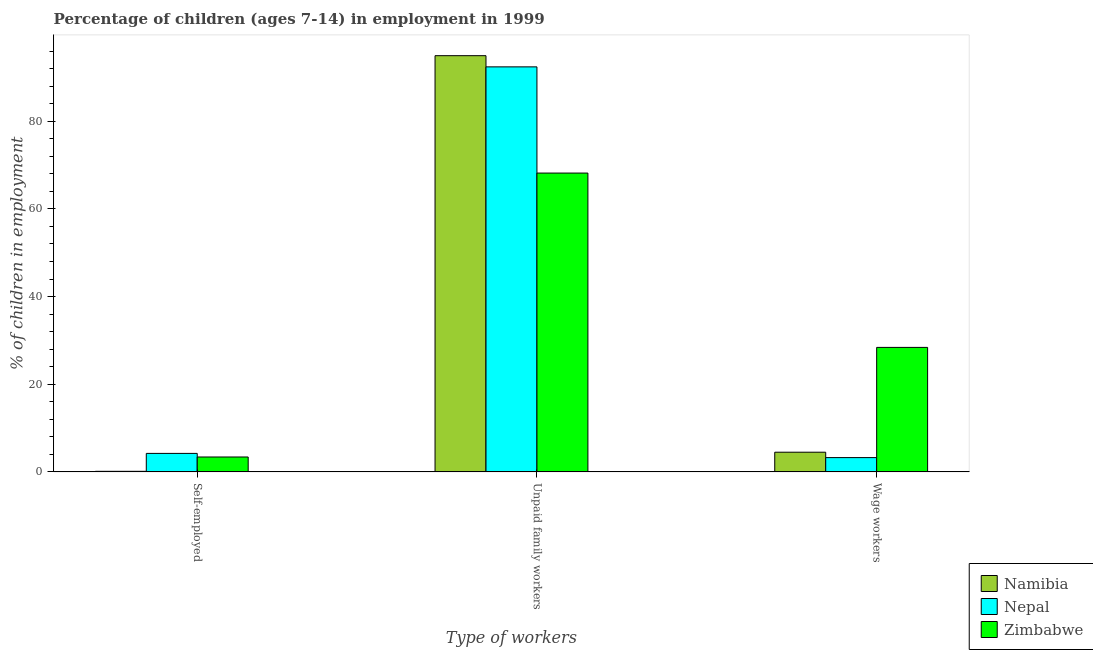How many different coloured bars are there?
Offer a very short reply. 3. How many bars are there on the 1st tick from the left?
Ensure brevity in your answer.  3. How many bars are there on the 3rd tick from the right?
Provide a succinct answer. 3. What is the label of the 1st group of bars from the left?
Keep it short and to the point. Self-employed. What is the percentage of children employed as unpaid family workers in Namibia?
Provide a short and direct response. 94.96. Across all countries, what is the maximum percentage of self employed children?
Provide a short and direct response. 4.23. Across all countries, what is the minimum percentage of children employed as wage workers?
Keep it short and to the point. 3.27. In which country was the percentage of self employed children maximum?
Offer a terse response. Nepal. In which country was the percentage of children employed as wage workers minimum?
Your answer should be compact. Nepal. What is the total percentage of children employed as wage workers in the graph?
Provide a succinct answer. 36.18. What is the difference between the percentage of children employed as unpaid family workers in Namibia and that in Nepal?
Offer a very short reply. 2.55. What is the difference between the percentage of children employed as unpaid family workers in Zimbabwe and the percentage of self employed children in Nepal?
Offer a very short reply. 63.95. What is the average percentage of children employed as wage workers per country?
Ensure brevity in your answer.  12.06. What is the difference between the percentage of children employed as unpaid family workers and percentage of children employed as wage workers in Namibia?
Make the answer very short. 90.46. What is the ratio of the percentage of children employed as wage workers in Zimbabwe to that in Nepal?
Your answer should be very brief. 8.69. Is the percentage of self employed children in Namibia less than that in Nepal?
Provide a short and direct response. Yes. What is the difference between the highest and the second highest percentage of self employed children?
Your answer should be very brief. 0.82. What is the difference between the highest and the lowest percentage of self employed children?
Provide a short and direct response. 4.09. What does the 3rd bar from the left in Unpaid family workers represents?
Provide a succinct answer. Zimbabwe. What does the 1st bar from the right in Unpaid family workers represents?
Ensure brevity in your answer.  Zimbabwe. Is it the case that in every country, the sum of the percentage of self employed children and percentage of children employed as unpaid family workers is greater than the percentage of children employed as wage workers?
Ensure brevity in your answer.  Yes. How many bars are there?
Offer a very short reply. 9. Does the graph contain any zero values?
Your response must be concise. No. Does the graph contain grids?
Provide a succinct answer. No. Where does the legend appear in the graph?
Give a very brief answer. Bottom right. How are the legend labels stacked?
Ensure brevity in your answer.  Vertical. What is the title of the graph?
Offer a very short reply. Percentage of children (ages 7-14) in employment in 1999. Does "Turkmenistan" appear as one of the legend labels in the graph?
Offer a terse response. No. What is the label or title of the X-axis?
Your answer should be very brief. Type of workers. What is the label or title of the Y-axis?
Offer a very short reply. % of children in employment. What is the % of children in employment in Namibia in Self-employed?
Provide a succinct answer. 0.14. What is the % of children in employment in Nepal in Self-employed?
Your response must be concise. 4.23. What is the % of children in employment of Zimbabwe in Self-employed?
Your response must be concise. 3.41. What is the % of children in employment of Namibia in Unpaid family workers?
Keep it short and to the point. 94.96. What is the % of children in employment of Nepal in Unpaid family workers?
Provide a short and direct response. 92.41. What is the % of children in employment in Zimbabwe in Unpaid family workers?
Offer a terse response. 68.18. What is the % of children in employment in Namibia in Wage workers?
Provide a short and direct response. 4.5. What is the % of children in employment of Nepal in Wage workers?
Offer a terse response. 3.27. What is the % of children in employment in Zimbabwe in Wage workers?
Make the answer very short. 28.41. Across all Type of workers, what is the maximum % of children in employment of Namibia?
Provide a short and direct response. 94.96. Across all Type of workers, what is the maximum % of children in employment in Nepal?
Offer a very short reply. 92.41. Across all Type of workers, what is the maximum % of children in employment in Zimbabwe?
Your answer should be compact. 68.18. Across all Type of workers, what is the minimum % of children in employment of Namibia?
Your answer should be very brief. 0.14. Across all Type of workers, what is the minimum % of children in employment of Nepal?
Provide a succinct answer. 3.27. Across all Type of workers, what is the minimum % of children in employment of Zimbabwe?
Make the answer very short. 3.41. What is the total % of children in employment in Namibia in the graph?
Give a very brief answer. 99.6. What is the total % of children in employment in Nepal in the graph?
Provide a short and direct response. 99.91. What is the difference between the % of children in employment of Namibia in Self-employed and that in Unpaid family workers?
Offer a terse response. -94.82. What is the difference between the % of children in employment of Nepal in Self-employed and that in Unpaid family workers?
Offer a terse response. -88.18. What is the difference between the % of children in employment in Zimbabwe in Self-employed and that in Unpaid family workers?
Make the answer very short. -64.77. What is the difference between the % of children in employment in Namibia in Self-employed and that in Wage workers?
Offer a very short reply. -4.36. What is the difference between the % of children in employment of Namibia in Unpaid family workers and that in Wage workers?
Ensure brevity in your answer.  90.46. What is the difference between the % of children in employment in Nepal in Unpaid family workers and that in Wage workers?
Offer a terse response. 89.14. What is the difference between the % of children in employment of Zimbabwe in Unpaid family workers and that in Wage workers?
Make the answer very short. 39.77. What is the difference between the % of children in employment of Namibia in Self-employed and the % of children in employment of Nepal in Unpaid family workers?
Your answer should be compact. -92.27. What is the difference between the % of children in employment of Namibia in Self-employed and the % of children in employment of Zimbabwe in Unpaid family workers?
Offer a very short reply. -68.04. What is the difference between the % of children in employment of Nepal in Self-employed and the % of children in employment of Zimbabwe in Unpaid family workers?
Provide a short and direct response. -63.95. What is the difference between the % of children in employment in Namibia in Self-employed and the % of children in employment in Nepal in Wage workers?
Ensure brevity in your answer.  -3.13. What is the difference between the % of children in employment in Namibia in Self-employed and the % of children in employment in Zimbabwe in Wage workers?
Your response must be concise. -28.27. What is the difference between the % of children in employment of Nepal in Self-employed and the % of children in employment of Zimbabwe in Wage workers?
Your answer should be very brief. -24.18. What is the difference between the % of children in employment of Namibia in Unpaid family workers and the % of children in employment of Nepal in Wage workers?
Your response must be concise. 91.69. What is the difference between the % of children in employment in Namibia in Unpaid family workers and the % of children in employment in Zimbabwe in Wage workers?
Provide a succinct answer. 66.55. What is the difference between the % of children in employment of Nepal in Unpaid family workers and the % of children in employment of Zimbabwe in Wage workers?
Give a very brief answer. 64. What is the average % of children in employment in Namibia per Type of workers?
Provide a succinct answer. 33.2. What is the average % of children in employment in Nepal per Type of workers?
Keep it short and to the point. 33.3. What is the average % of children in employment of Zimbabwe per Type of workers?
Provide a short and direct response. 33.33. What is the difference between the % of children in employment of Namibia and % of children in employment of Nepal in Self-employed?
Ensure brevity in your answer.  -4.09. What is the difference between the % of children in employment in Namibia and % of children in employment in Zimbabwe in Self-employed?
Give a very brief answer. -3.27. What is the difference between the % of children in employment in Nepal and % of children in employment in Zimbabwe in Self-employed?
Offer a terse response. 0.82. What is the difference between the % of children in employment in Namibia and % of children in employment in Nepal in Unpaid family workers?
Keep it short and to the point. 2.55. What is the difference between the % of children in employment in Namibia and % of children in employment in Zimbabwe in Unpaid family workers?
Make the answer very short. 26.78. What is the difference between the % of children in employment in Nepal and % of children in employment in Zimbabwe in Unpaid family workers?
Keep it short and to the point. 24.23. What is the difference between the % of children in employment of Namibia and % of children in employment of Nepal in Wage workers?
Offer a very short reply. 1.23. What is the difference between the % of children in employment in Namibia and % of children in employment in Zimbabwe in Wage workers?
Ensure brevity in your answer.  -23.91. What is the difference between the % of children in employment of Nepal and % of children in employment of Zimbabwe in Wage workers?
Ensure brevity in your answer.  -25.14. What is the ratio of the % of children in employment in Namibia in Self-employed to that in Unpaid family workers?
Your response must be concise. 0. What is the ratio of the % of children in employment of Nepal in Self-employed to that in Unpaid family workers?
Make the answer very short. 0.05. What is the ratio of the % of children in employment in Zimbabwe in Self-employed to that in Unpaid family workers?
Provide a short and direct response. 0.05. What is the ratio of the % of children in employment of Namibia in Self-employed to that in Wage workers?
Give a very brief answer. 0.03. What is the ratio of the % of children in employment of Nepal in Self-employed to that in Wage workers?
Your response must be concise. 1.29. What is the ratio of the % of children in employment in Zimbabwe in Self-employed to that in Wage workers?
Your answer should be compact. 0.12. What is the ratio of the % of children in employment in Namibia in Unpaid family workers to that in Wage workers?
Provide a short and direct response. 21.1. What is the ratio of the % of children in employment of Nepal in Unpaid family workers to that in Wage workers?
Your response must be concise. 28.26. What is the ratio of the % of children in employment in Zimbabwe in Unpaid family workers to that in Wage workers?
Give a very brief answer. 2.4. What is the difference between the highest and the second highest % of children in employment in Namibia?
Your response must be concise. 90.46. What is the difference between the highest and the second highest % of children in employment of Nepal?
Ensure brevity in your answer.  88.18. What is the difference between the highest and the second highest % of children in employment of Zimbabwe?
Offer a very short reply. 39.77. What is the difference between the highest and the lowest % of children in employment of Namibia?
Make the answer very short. 94.82. What is the difference between the highest and the lowest % of children in employment in Nepal?
Make the answer very short. 89.14. What is the difference between the highest and the lowest % of children in employment of Zimbabwe?
Give a very brief answer. 64.77. 